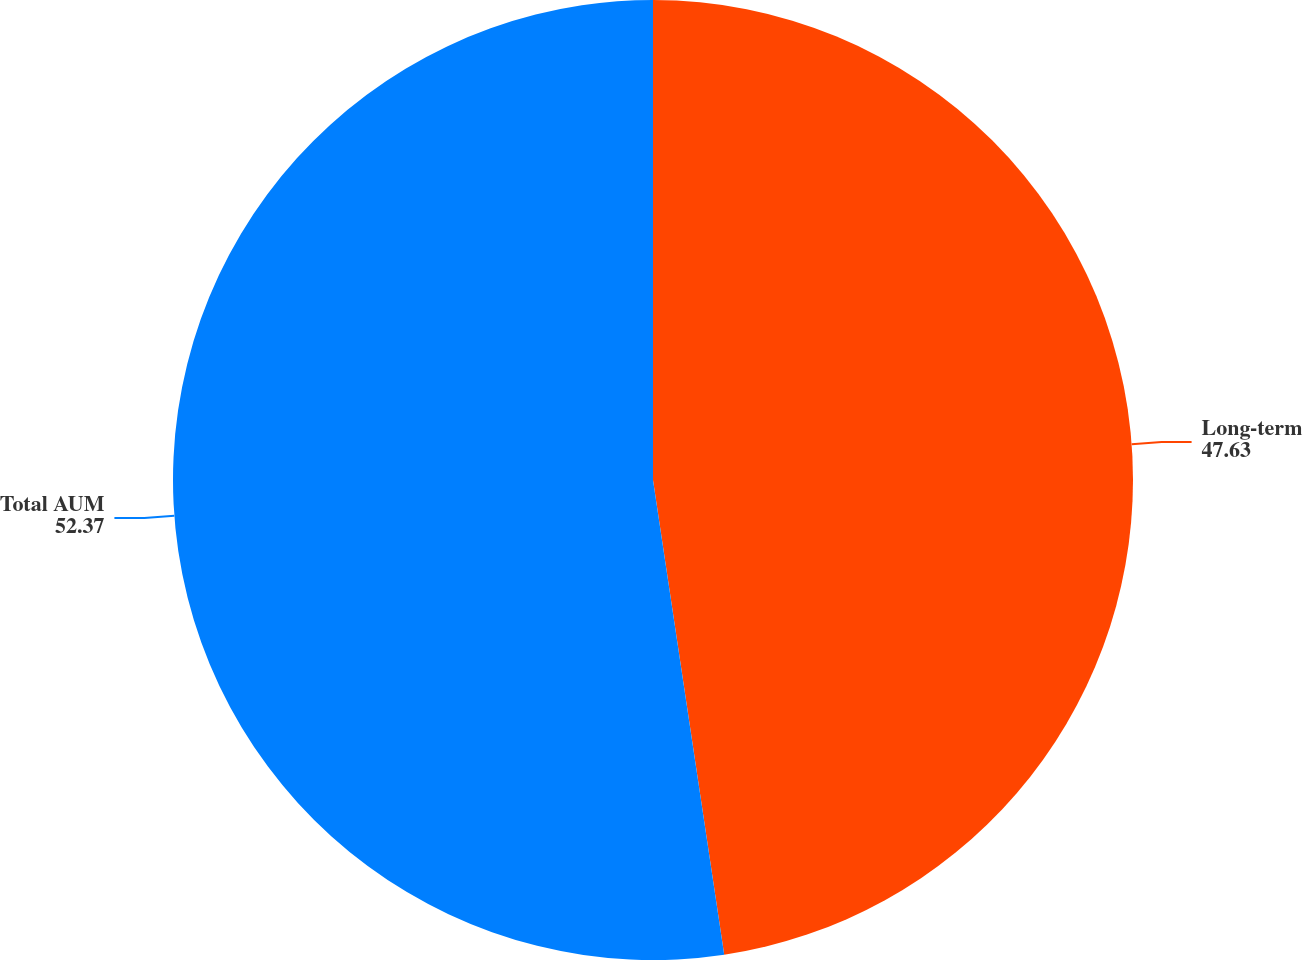Convert chart to OTSL. <chart><loc_0><loc_0><loc_500><loc_500><pie_chart><fcel>Long-term<fcel>Total AUM<nl><fcel>47.63%<fcel>52.37%<nl></chart> 